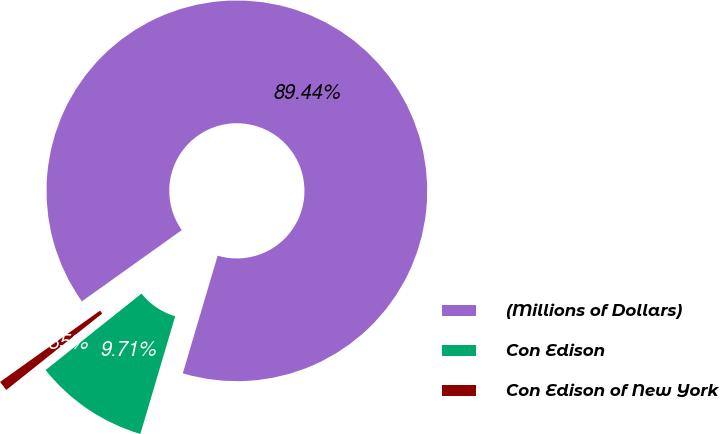Convert chart. <chart><loc_0><loc_0><loc_500><loc_500><pie_chart><fcel>(Millions of Dollars)<fcel>Con Edison<fcel>Con Edison of New York<nl><fcel>89.45%<fcel>9.71%<fcel>0.85%<nl></chart> 